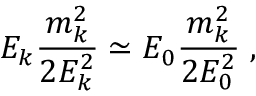Convert formula to latex. <formula><loc_0><loc_0><loc_500><loc_500>E _ { k } \frac { m _ { k } ^ { 2 } } { 2 E _ { k } ^ { 2 } } \simeq E _ { 0 } \frac { m _ { k } ^ { 2 } } { 2 E _ { 0 } ^ { 2 } } \, ,</formula> 